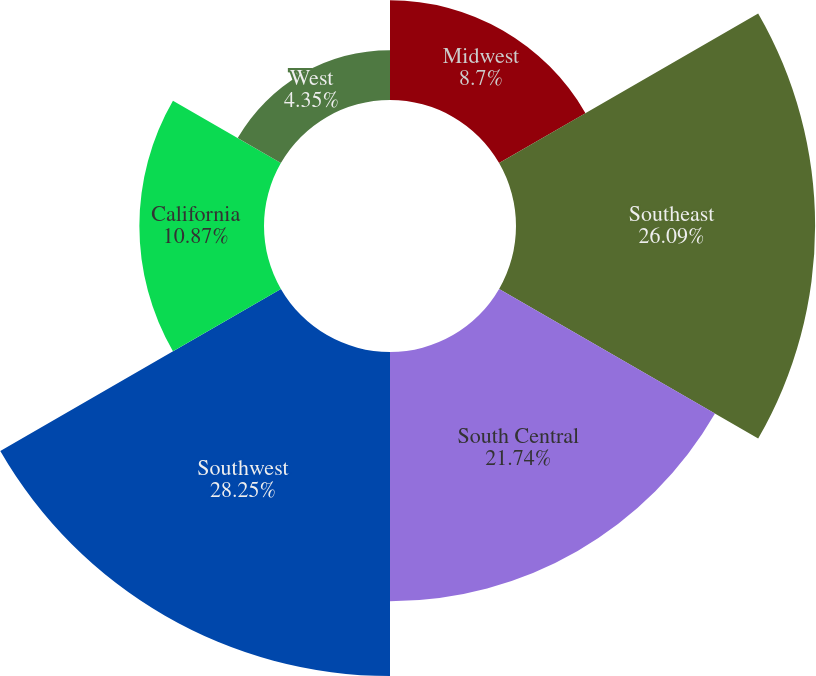Convert chart. <chart><loc_0><loc_0><loc_500><loc_500><pie_chart><fcel>Midwest<fcel>Southeast<fcel>South Central<fcel>Southwest<fcel>California<fcel>West<nl><fcel>8.7%<fcel>26.09%<fcel>21.74%<fcel>28.26%<fcel>10.87%<fcel>4.35%<nl></chart> 